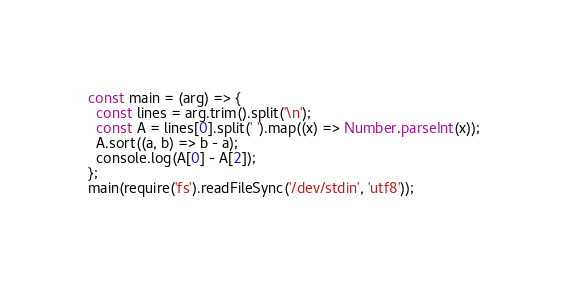Convert code to text. <code><loc_0><loc_0><loc_500><loc_500><_JavaScript_>const main = (arg) => {
  const lines = arg.trim().split('\n');
  const A = lines[0].split(' ').map((x) => Number.parseInt(x));
  A.sort((a, b) => b - a);
  console.log(A[0] - A[2]);
};
main(require('fs').readFileSync('/dev/stdin', 'utf8'));
</code> 